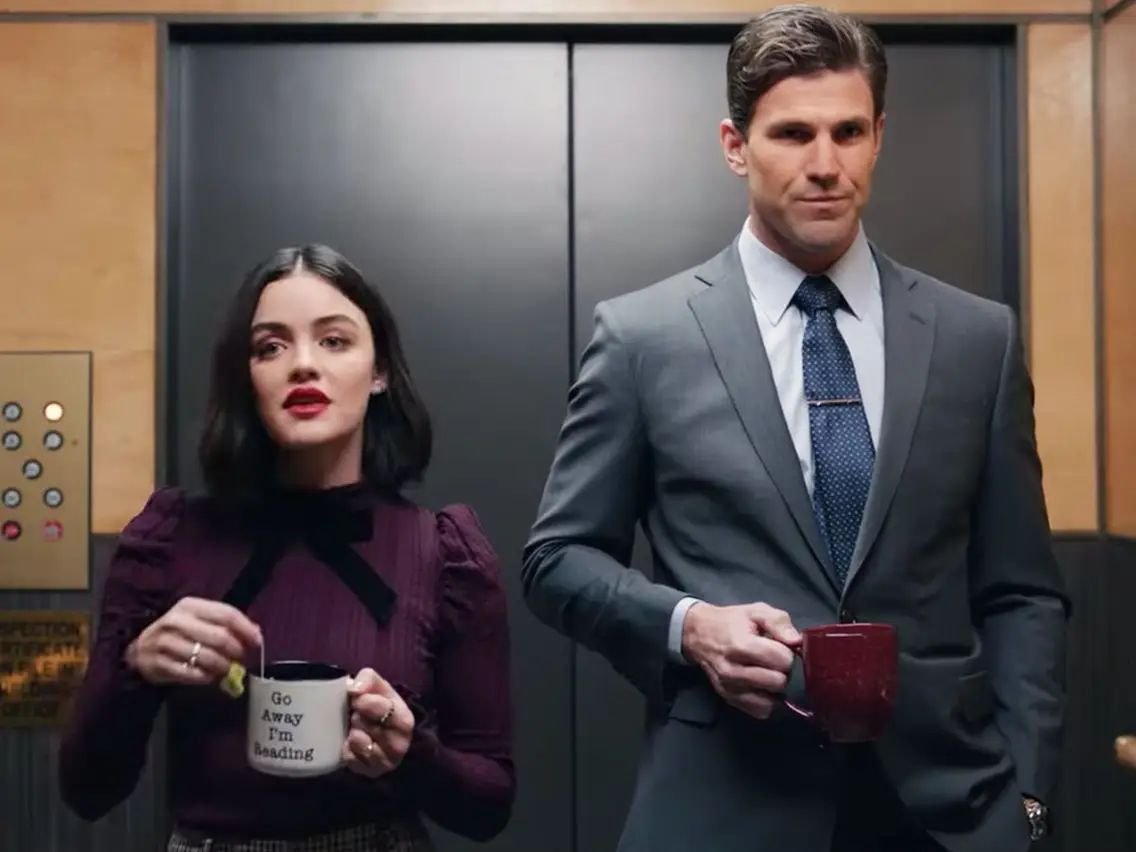Can you elaborate on the elements of the picture provided? In the image, there is a candid moment captured inside an elevator featuring actress Lucy Hale and a man in formal attire. Lucy Hale, standing on the left, holds a black mug that reads, 'Go Away I'm Reading.' She is dressed in a stylish purple blouse with a bow at the collar, and her expression appears somewhat surprised or curious. On the right, the man is dressed in a sharp gray suit paired with a blue tie and holds a red mug with a serious expression. The setting is the sleek modern interior of an elevator, complete with metallic walls and a panel of buttons visible on the left side of the frame. 